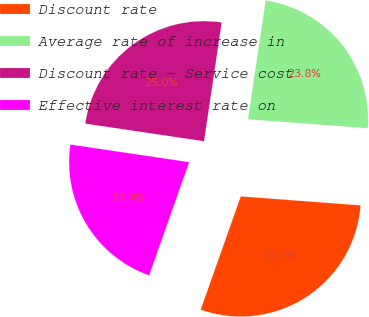Convert chart. <chart><loc_0><loc_0><loc_500><loc_500><pie_chart><fcel>Discount rate<fcel>Average rate of increase in<fcel>Discount rate - Service cost<fcel>Effective interest rate on<nl><fcel>29.22%<fcel>23.84%<fcel>25.0%<fcel>21.93%<nl></chart> 